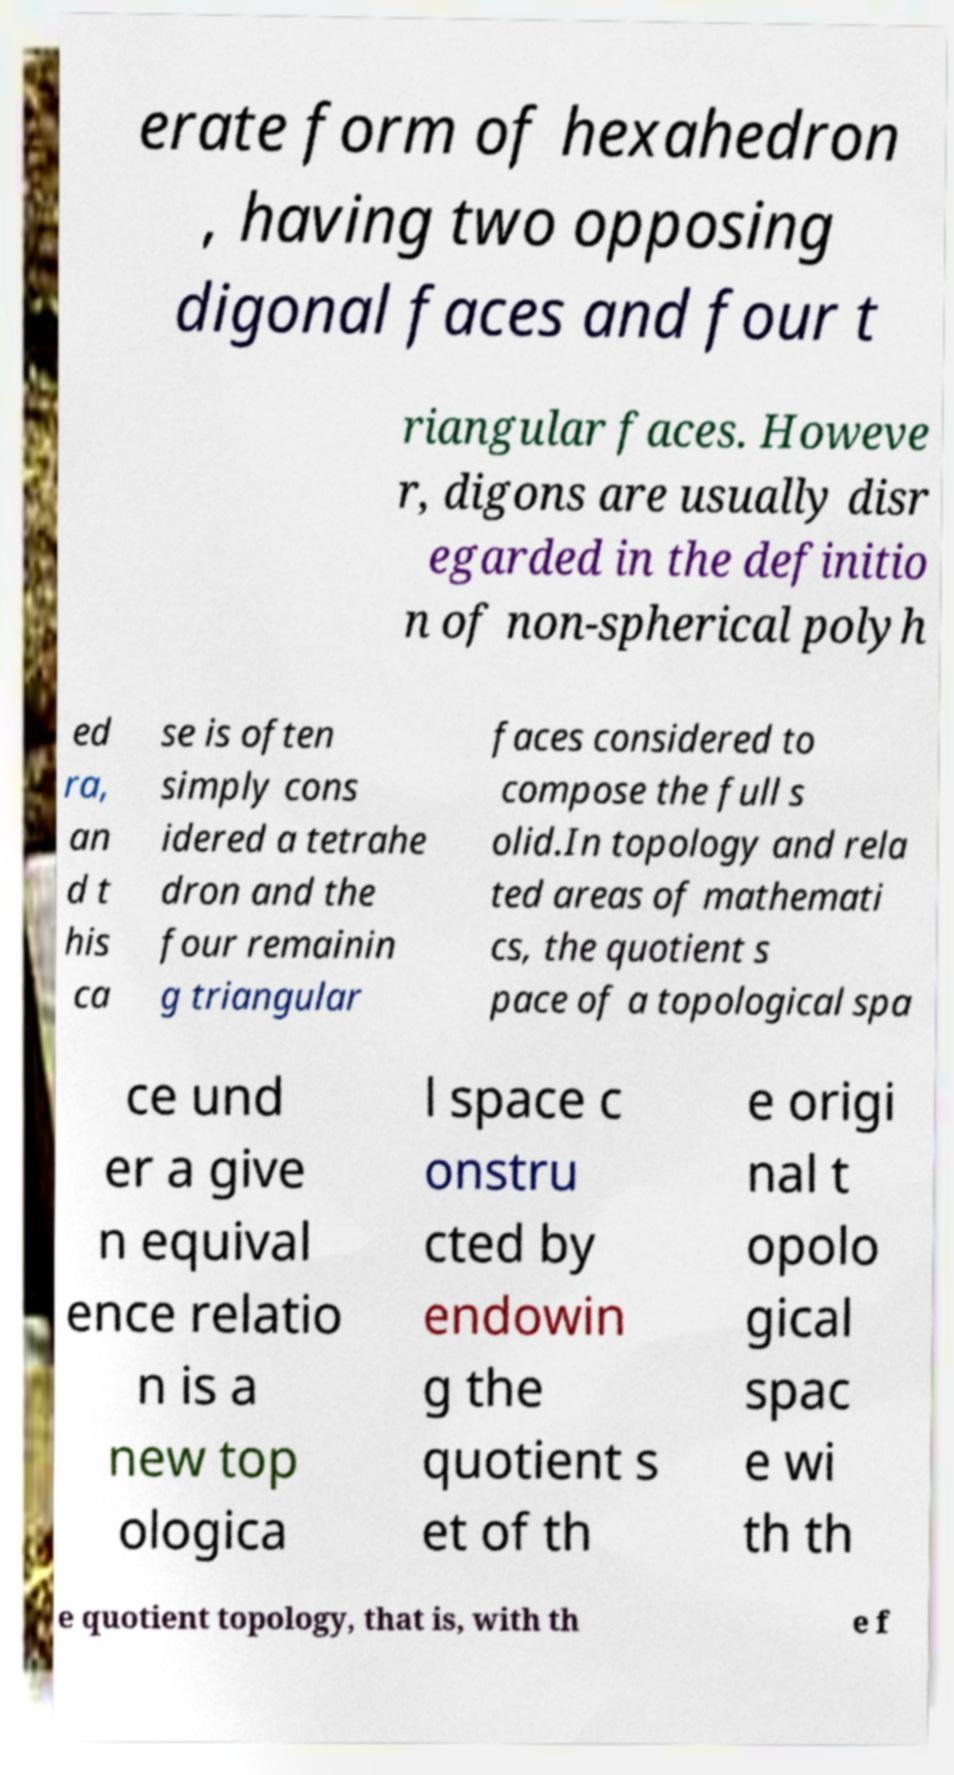Can you accurately transcribe the text from the provided image for me? erate form of hexahedron , having two opposing digonal faces and four t riangular faces. Howeve r, digons are usually disr egarded in the definitio n of non-spherical polyh ed ra, an d t his ca se is often simply cons idered a tetrahe dron and the four remainin g triangular faces considered to compose the full s olid.In topology and rela ted areas of mathemati cs, the quotient s pace of a topological spa ce und er a give n equival ence relatio n is a new top ologica l space c onstru cted by endowin g the quotient s et of th e origi nal t opolo gical spac e wi th th e quotient topology, that is, with th e f 